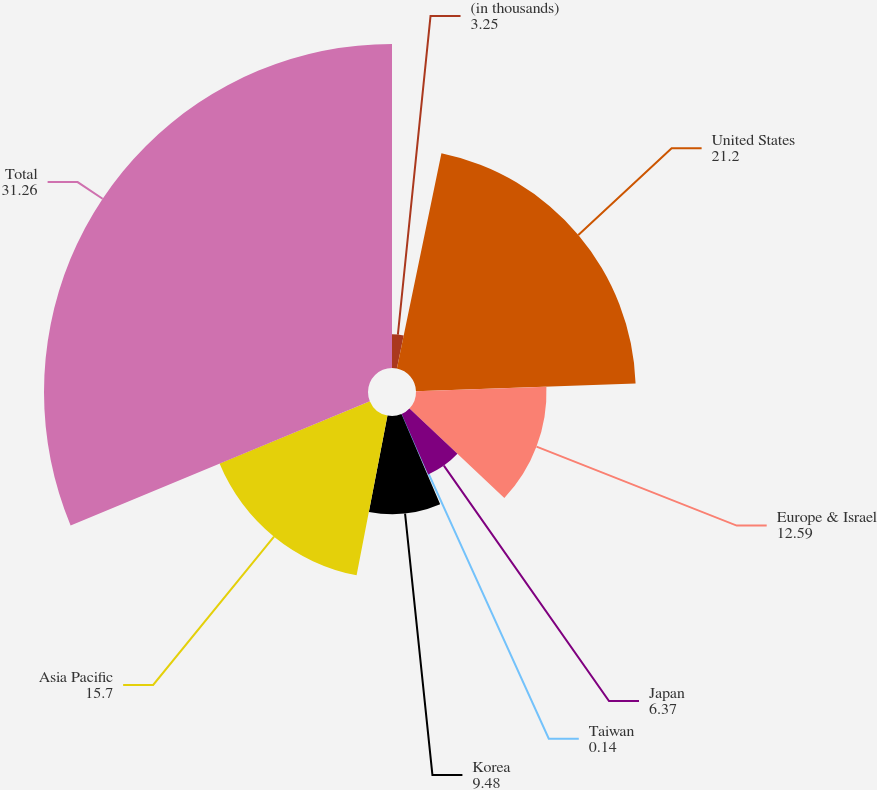<chart> <loc_0><loc_0><loc_500><loc_500><pie_chart><fcel>(in thousands)<fcel>United States<fcel>Europe & Israel<fcel>Japan<fcel>Taiwan<fcel>Korea<fcel>Asia Pacific<fcel>Total<nl><fcel>3.25%<fcel>21.2%<fcel>12.59%<fcel>6.37%<fcel>0.14%<fcel>9.48%<fcel>15.7%<fcel>31.26%<nl></chart> 